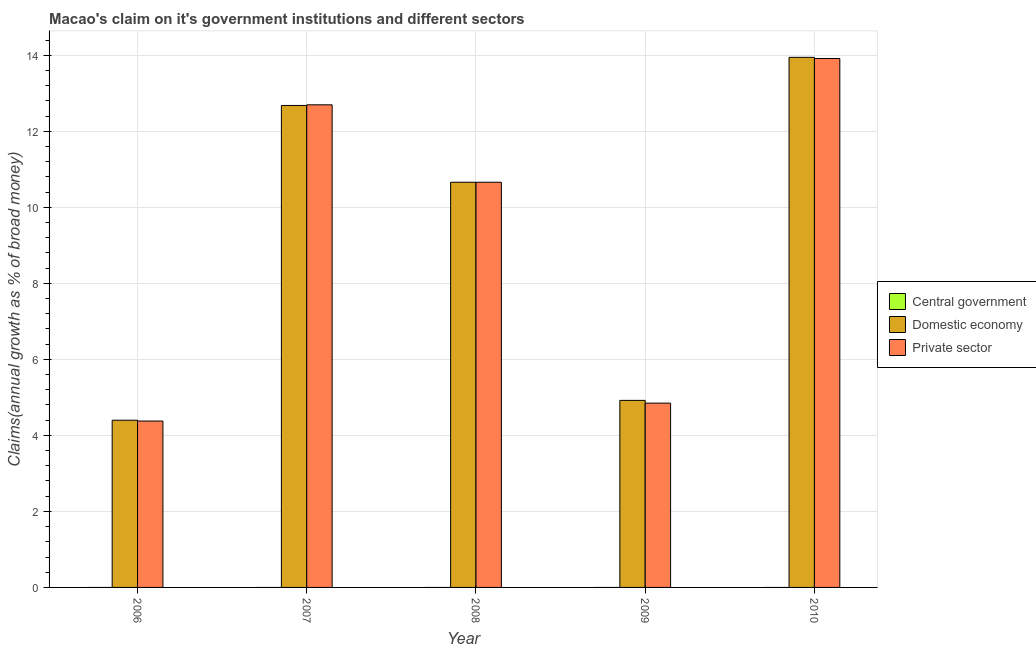Are the number of bars per tick equal to the number of legend labels?
Offer a terse response. No. Across all years, what is the maximum percentage of claim on the private sector?
Your response must be concise. 13.91. Across all years, what is the minimum percentage of claim on the private sector?
Your answer should be compact. 4.38. What is the total percentage of claim on the private sector in the graph?
Provide a short and direct response. 46.5. What is the difference between the percentage of claim on the private sector in 2006 and that in 2007?
Offer a very short reply. -8.32. What is the difference between the percentage of claim on the domestic economy in 2010 and the percentage of claim on the private sector in 2008?
Provide a succinct answer. 3.29. What is the average percentage of claim on the central government per year?
Keep it short and to the point. 0. In the year 2009, what is the difference between the percentage of claim on the domestic economy and percentage of claim on the central government?
Your answer should be compact. 0. In how many years, is the percentage of claim on the central government greater than 0.8 %?
Your answer should be very brief. 0. What is the ratio of the percentage of claim on the private sector in 2007 to that in 2009?
Give a very brief answer. 2.62. Is the percentage of claim on the private sector in 2006 less than that in 2008?
Offer a terse response. Yes. What is the difference between the highest and the second highest percentage of claim on the private sector?
Offer a terse response. 1.22. What is the difference between the highest and the lowest percentage of claim on the private sector?
Offer a terse response. 9.54. In how many years, is the percentage of claim on the central government greater than the average percentage of claim on the central government taken over all years?
Provide a succinct answer. 0. Is the sum of the percentage of claim on the domestic economy in 2006 and 2007 greater than the maximum percentage of claim on the central government across all years?
Make the answer very short. Yes. Is it the case that in every year, the sum of the percentage of claim on the central government and percentage of claim on the domestic economy is greater than the percentage of claim on the private sector?
Your answer should be very brief. No. How many bars are there?
Your answer should be compact. 10. How many years are there in the graph?
Make the answer very short. 5. What is the difference between two consecutive major ticks on the Y-axis?
Provide a succinct answer. 2. Where does the legend appear in the graph?
Make the answer very short. Center right. How many legend labels are there?
Give a very brief answer. 3. How are the legend labels stacked?
Your answer should be compact. Vertical. What is the title of the graph?
Your answer should be very brief. Macao's claim on it's government institutions and different sectors. Does "Communicable diseases" appear as one of the legend labels in the graph?
Your answer should be compact. No. What is the label or title of the X-axis?
Keep it short and to the point. Year. What is the label or title of the Y-axis?
Your response must be concise. Claims(annual growth as % of broad money). What is the Claims(annual growth as % of broad money) in Domestic economy in 2006?
Ensure brevity in your answer.  4.4. What is the Claims(annual growth as % of broad money) of Private sector in 2006?
Ensure brevity in your answer.  4.38. What is the Claims(annual growth as % of broad money) in Central government in 2007?
Your response must be concise. 0. What is the Claims(annual growth as % of broad money) of Domestic economy in 2007?
Your response must be concise. 12.68. What is the Claims(annual growth as % of broad money) of Private sector in 2007?
Offer a very short reply. 12.7. What is the Claims(annual growth as % of broad money) in Central government in 2008?
Keep it short and to the point. 0. What is the Claims(annual growth as % of broad money) in Domestic economy in 2008?
Your response must be concise. 10.66. What is the Claims(annual growth as % of broad money) in Private sector in 2008?
Your answer should be compact. 10.66. What is the Claims(annual growth as % of broad money) in Domestic economy in 2009?
Offer a terse response. 4.92. What is the Claims(annual growth as % of broad money) of Private sector in 2009?
Offer a very short reply. 4.85. What is the Claims(annual growth as % of broad money) of Central government in 2010?
Keep it short and to the point. 0. What is the Claims(annual growth as % of broad money) in Domestic economy in 2010?
Ensure brevity in your answer.  13.95. What is the Claims(annual growth as % of broad money) in Private sector in 2010?
Keep it short and to the point. 13.91. Across all years, what is the maximum Claims(annual growth as % of broad money) of Domestic economy?
Provide a short and direct response. 13.95. Across all years, what is the maximum Claims(annual growth as % of broad money) of Private sector?
Offer a very short reply. 13.91. Across all years, what is the minimum Claims(annual growth as % of broad money) in Domestic economy?
Your response must be concise. 4.4. Across all years, what is the minimum Claims(annual growth as % of broad money) of Private sector?
Your response must be concise. 4.38. What is the total Claims(annual growth as % of broad money) of Domestic economy in the graph?
Offer a very short reply. 46.6. What is the total Claims(annual growth as % of broad money) in Private sector in the graph?
Give a very brief answer. 46.5. What is the difference between the Claims(annual growth as % of broad money) of Domestic economy in 2006 and that in 2007?
Provide a short and direct response. -8.28. What is the difference between the Claims(annual growth as % of broad money) of Private sector in 2006 and that in 2007?
Ensure brevity in your answer.  -8.32. What is the difference between the Claims(annual growth as % of broad money) of Domestic economy in 2006 and that in 2008?
Your answer should be very brief. -6.26. What is the difference between the Claims(annual growth as % of broad money) of Private sector in 2006 and that in 2008?
Offer a terse response. -6.28. What is the difference between the Claims(annual growth as % of broad money) in Domestic economy in 2006 and that in 2009?
Make the answer very short. -0.52. What is the difference between the Claims(annual growth as % of broad money) of Private sector in 2006 and that in 2009?
Give a very brief answer. -0.47. What is the difference between the Claims(annual growth as % of broad money) in Domestic economy in 2006 and that in 2010?
Give a very brief answer. -9.55. What is the difference between the Claims(annual growth as % of broad money) of Private sector in 2006 and that in 2010?
Provide a succinct answer. -9.54. What is the difference between the Claims(annual growth as % of broad money) in Domestic economy in 2007 and that in 2008?
Provide a succinct answer. 2.02. What is the difference between the Claims(annual growth as % of broad money) of Private sector in 2007 and that in 2008?
Your answer should be very brief. 2.04. What is the difference between the Claims(annual growth as % of broad money) in Domestic economy in 2007 and that in 2009?
Your answer should be compact. 7.76. What is the difference between the Claims(annual growth as % of broad money) of Private sector in 2007 and that in 2009?
Provide a short and direct response. 7.85. What is the difference between the Claims(annual growth as % of broad money) of Domestic economy in 2007 and that in 2010?
Ensure brevity in your answer.  -1.27. What is the difference between the Claims(annual growth as % of broad money) of Private sector in 2007 and that in 2010?
Make the answer very short. -1.22. What is the difference between the Claims(annual growth as % of broad money) of Domestic economy in 2008 and that in 2009?
Offer a terse response. 5.74. What is the difference between the Claims(annual growth as % of broad money) of Private sector in 2008 and that in 2009?
Offer a very short reply. 5.81. What is the difference between the Claims(annual growth as % of broad money) of Domestic economy in 2008 and that in 2010?
Your answer should be very brief. -3.29. What is the difference between the Claims(annual growth as % of broad money) in Private sector in 2008 and that in 2010?
Offer a very short reply. -3.25. What is the difference between the Claims(annual growth as % of broad money) in Domestic economy in 2009 and that in 2010?
Offer a very short reply. -9.02. What is the difference between the Claims(annual growth as % of broad money) in Private sector in 2009 and that in 2010?
Ensure brevity in your answer.  -9.07. What is the difference between the Claims(annual growth as % of broad money) of Domestic economy in 2006 and the Claims(annual growth as % of broad money) of Private sector in 2007?
Your answer should be compact. -8.3. What is the difference between the Claims(annual growth as % of broad money) in Domestic economy in 2006 and the Claims(annual growth as % of broad money) in Private sector in 2008?
Provide a succinct answer. -6.26. What is the difference between the Claims(annual growth as % of broad money) in Domestic economy in 2006 and the Claims(annual growth as % of broad money) in Private sector in 2009?
Provide a short and direct response. -0.45. What is the difference between the Claims(annual growth as % of broad money) of Domestic economy in 2006 and the Claims(annual growth as % of broad money) of Private sector in 2010?
Your answer should be compact. -9.52. What is the difference between the Claims(annual growth as % of broad money) of Domestic economy in 2007 and the Claims(annual growth as % of broad money) of Private sector in 2008?
Your answer should be compact. 2.02. What is the difference between the Claims(annual growth as % of broad money) in Domestic economy in 2007 and the Claims(annual growth as % of broad money) in Private sector in 2009?
Make the answer very short. 7.83. What is the difference between the Claims(annual growth as % of broad money) of Domestic economy in 2007 and the Claims(annual growth as % of broad money) of Private sector in 2010?
Keep it short and to the point. -1.24. What is the difference between the Claims(annual growth as % of broad money) in Domestic economy in 2008 and the Claims(annual growth as % of broad money) in Private sector in 2009?
Ensure brevity in your answer.  5.81. What is the difference between the Claims(annual growth as % of broad money) in Domestic economy in 2008 and the Claims(annual growth as % of broad money) in Private sector in 2010?
Keep it short and to the point. -3.25. What is the difference between the Claims(annual growth as % of broad money) of Domestic economy in 2009 and the Claims(annual growth as % of broad money) of Private sector in 2010?
Make the answer very short. -8.99. What is the average Claims(annual growth as % of broad money) in Domestic economy per year?
Provide a succinct answer. 9.32. What is the average Claims(annual growth as % of broad money) in Private sector per year?
Give a very brief answer. 9.3. In the year 2006, what is the difference between the Claims(annual growth as % of broad money) in Domestic economy and Claims(annual growth as % of broad money) in Private sector?
Make the answer very short. 0.02. In the year 2007, what is the difference between the Claims(annual growth as % of broad money) in Domestic economy and Claims(annual growth as % of broad money) in Private sector?
Your response must be concise. -0.02. In the year 2009, what is the difference between the Claims(annual growth as % of broad money) in Domestic economy and Claims(annual growth as % of broad money) in Private sector?
Offer a very short reply. 0.07. In the year 2010, what is the difference between the Claims(annual growth as % of broad money) in Domestic economy and Claims(annual growth as % of broad money) in Private sector?
Keep it short and to the point. 0.03. What is the ratio of the Claims(annual growth as % of broad money) of Domestic economy in 2006 to that in 2007?
Provide a succinct answer. 0.35. What is the ratio of the Claims(annual growth as % of broad money) in Private sector in 2006 to that in 2007?
Provide a succinct answer. 0.34. What is the ratio of the Claims(annual growth as % of broad money) of Domestic economy in 2006 to that in 2008?
Make the answer very short. 0.41. What is the ratio of the Claims(annual growth as % of broad money) in Private sector in 2006 to that in 2008?
Offer a very short reply. 0.41. What is the ratio of the Claims(annual growth as % of broad money) of Domestic economy in 2006 to that in 2009?
Your response must be concise. 0.89. What is the ratio of the Claims(annual growth as % of broad money) of Private sector in 2006 to that in 2009?
Offer a very short reply. 0.9. What is the ratio of the Claims(annual growth as % of broad money) in Domestic economy in 2006 to that in 2010?
Your answer should be very brief. 0.32. What is the ratio of the Claims(annual growth as % of broad money) in Private sector in 2006 to that in 2010?
Keep it short and to the point. 0.31. What is the ratio of the Claims(annual growth as % of broad money) of Domestic economy in 2007 to that in 2008?
Your response must be concise. 1.19. What is the ratio of the Claims(annual growth as % of broad money) of Private sector in 2007 to that in 2008?
Keep it short and to the point. 1.19. What is the ratio of the Claims(annual growth as % of broad money) of Domestic economy in 2007 to that in 2009?
Ensure brevity in your answer.  2.58. What is the ratio of the Claims(annual growth as % of broad money) in Private sector in 2007 to that in 2009?
Make the answer very short. 2.62. What is the ratio of the Claims(annual growth as % of broad money) in Domestic economy in 2007 to that in 2010?
Provide a short and direct response. 0.91. What is the ratio of the Claims(annual growth as % of broad money) in Private sector in 2007 to that in 2010?
Provide a succinct answer. 0.91. What is the ratio of the Claims(annual growth as % of broad money) of Domestic economy in 2008 to that in 2009?
Provide a short and direct response. 2.17. What is the ratio of the Claims(annual growth as % of broad money) in Private sector in 2008 to that in 2009?
Provide a short and direct response. 2.2. What is the ratio of the Claims(annual growth as % of broad money) of Domestic economy in 2008 to that in 2010?
Provide a short and direct response. 0.76. What is the ratio of the Claims(annual growth as % of broad money) of Private sector in 2008 to that in 2010?
Provide a succinct answer. 0.77. What is the ratio of the Claims(annual growth as % of broad money) of Domestic economy in 2009 to that in 2010?
Your answer should be very brief. 0.35. What is the ratio of the Claims(annual growth as % of broad money) of Private sector in 2009 to that in 2010?
Make the answer very short. 0.35. What is the difference between the highest and the second highest Claims(annual growth as % of broad money) of Domestic economy?
Offer a terse response. 1.27. What is the difference between the highest and the second highest Claims(annual growth as % of broad money) in Private sector?
Your answer should be very brief. 1.22. What is the difference between the highest and the lowest Claims(annual growth as % of broad money) of Domestic economy?
Make the answer very short. 9.55. What is the difference between the highest and the lowest Claims(annual growth as % of broad money) of Private sector?
Your response must be concise. 9.54. 